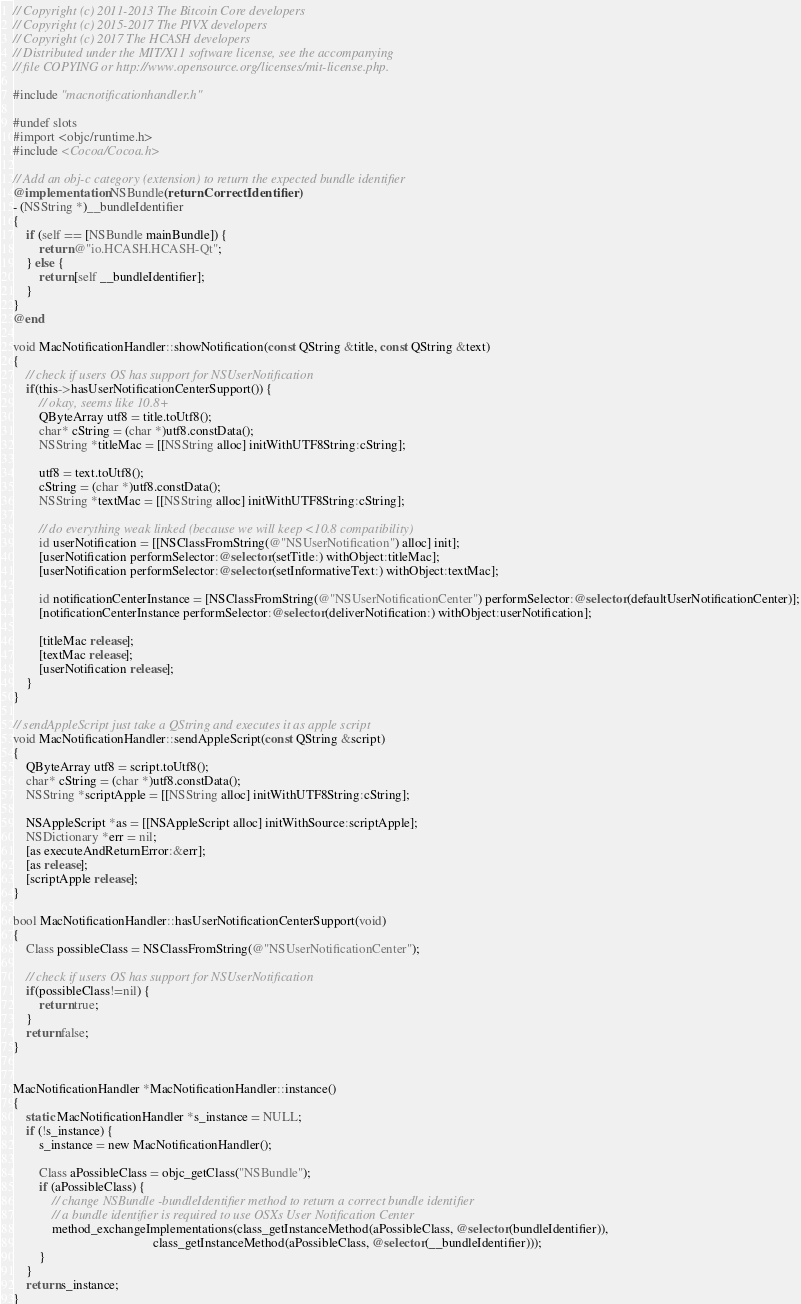<code> <loc_0><loc_0><loc_500><loc_500><_ObjectiveC_>// Copyright (c) 2011-2013 The Bitcoin Core developers
// Copyright (c) 2015-2017 The PIVX developers
// Copyright (c) 2017 The HCASH developers
// Distributed under the MIT/X11 software license, see the accompanying
// file COPYING or http://www.opensource.org/licenses/mit-license.php.

#include "macnotificationhandler.h"

#undef slots
#import <objc/runtime.h>
#include <Cocoa/Cocoa.h>

// Add an obj-c category (extension) to return the expected bundle identifier
@implementation NSBundle(returnCorrectIdentifier)
- (NSString *)__bundleIdentifier
{
    if (self == [NSBundle mainBundle]) {
        return @"io.HCASH.HCASH-Qt";
    } else {
        return [self __bundleIdentifier];
    }
}
@end

void MacNotificationHandler::showNotification(const QString &title, const QString &text)
{
    // check if users OS has support for NSUserNotification
    if(this->hasUserNotificationCenterSupport()) {
        // okay, seems like 10.8+
        QByteArray utf8 = title.toUtf8();
        char* cString = (char *)utf8.constData();
        NSString *titleMac = [[NSString alloc] initWithUTF8String:cString];

        utf8 = text.toUtf8();
        cString = (char *)utf8.constData();
        NSString *textMac = [[NSString alloc] initWithUTF8String:cString];

        // do everything weak linked (because we will keep <10.8 compatibility)
        id userNotification = [[NSClassFromString(@"NSUserNotification") alloc] init];
        [userNotification performSelector:@selector(setTitle:) withObject:titleMac];
        [userNotification performSelector:@selector(setInformativeText:) withObject:textMac];

        id notificationCenterInstance = [NSClassFromString(@"NSUserNotificationCenter") performSelector:@selector(defaultUserNotificationCenter)];
        [notificationCenterInstance performSelector:@selector(deliverNotification:) withObject:userNotification];

        [titleMac release];
        [textMac release];
        [userNotification release];
    }
}

// sendAppleScript just take a QString and executes it as apple script
void MacNotificationHandler::sendAppleScript(const QString &script)
{
    QByteArray utf8 = script.toUtf8();
    char* cString = (char *)utf8.constData();
    NSString *scriptApple = [[NSString alloc] initWithUTF8String:cString];

    NSAppleScript *as = [[NSAppleScript alloc] initWithSource:scriptApple];
    NSDictionary *err = nil;
    [as executeAndReturnError:&err];
    [as release];
    [scriptApple release];
}

bool MacNotificationHandler::hasUserNotificationCenterSupport(void)
{
    Class possibleClass = NSClassFromString(@"NSUserNotificationCenter");

    // check if users OS has support for NSUserNotification
    if(possibleClass!=nil) {
        return true;
    }
    return false;
}


MacNotificationHandler *MacNotificationHandler::instance()
{
    static MacNotificationHandler *s_instance = NULL;
    if (!s_instance) {
        s_instance = new MacNotificationHandler();
        
        Class aPossibleClass = objc_getClass("NSBundle");
        if (aPossibleClass) {
            // change NSBundle -bundleIdentifier method to return a correct bundle identifier
            // a bundle identifier is required to use OSXs User Notification Center
            method_exchangeImplementations(class_getInstanceMethod(aPossibleClass, @selector(bundleIdentifier)),
                                           class_getInstanceMethod(aPossibleClass, @selector(__bundleIdentifier)));
        }
    }
    return s_instance;
}
</code> 